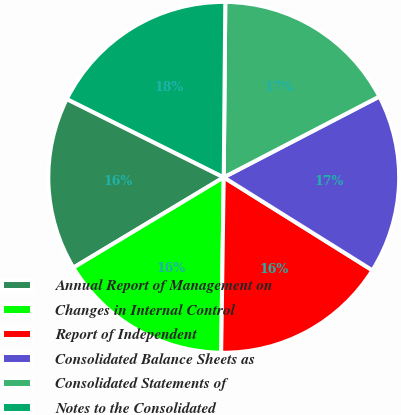<chart> <loc_0><loc_0><loc_500><loc_500><pie_chart><fcel>Annual Report of Management on<fcel>Changes in Internal Control<fcel>Report of Independent<fcel>Consolidated Balance Sheets as<fcel>Consolidated Statements of<fcel>Notes to the Consolidated<nl><fcel>15.98%<fcel>16.16%<fcel>16.34%<fcel>16.52%<fcel>17.24%<fcel>17.78%<nl></chart> 